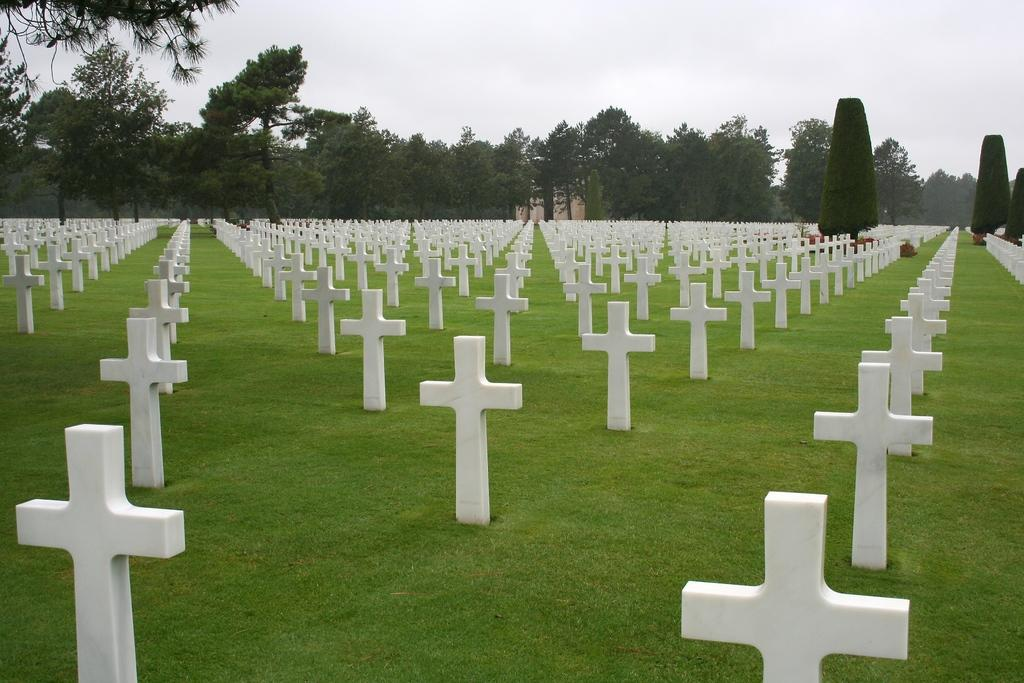What type of vegetation is at the bottom of the image? There is grass at the bottom of the image. What is the main feature in the image? There is a group of crosses in the image. What can be seen in the background of the image? There are trees in the background of the image. What is visible at the top of the image? The sky is visible at the top of the image. What type of rod is used by the spy in the image? There is no rod or spy present in the image. How does the sponge help clean the crosses in the image? There is no sponge present in the image, and the crosses do not require cleaning. 